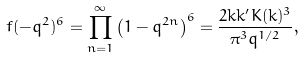<formula> <loc_0><loc_0><loc_500><loc_500>f ( - q ^ { 2 } ) ^ { 6 } = \prod ^ { \infty } _ { n = 1 } \left ( 1 - q ^ { 2 n } \right ) ^ { 6 } = \frac { 2 k k ^ { \prime } K ( k ) ^ { 3 } } { \pi ^ { 3 } q ^ { 1 / 2 } } ,</formula> 